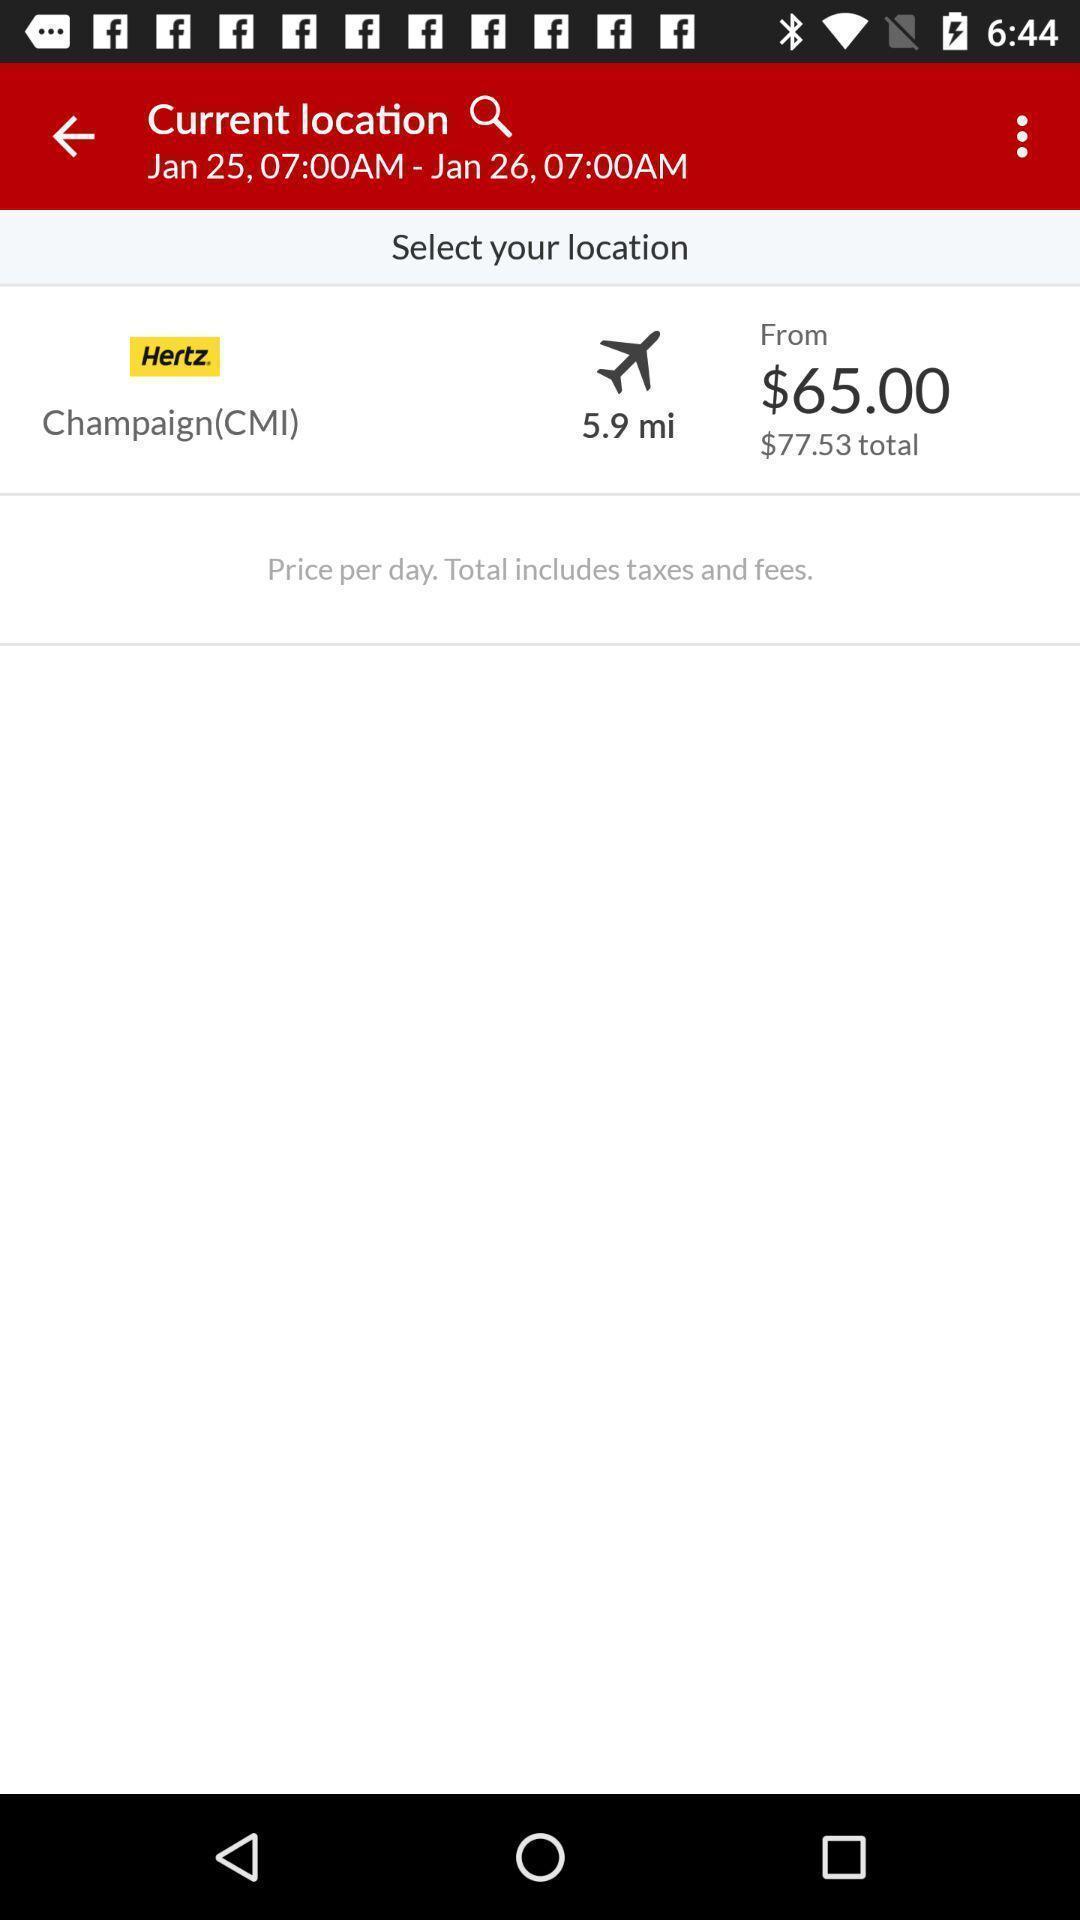Describe this image in words. Pages the showing the current location with the price. 